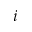Convert formula to latex. <formula><loc_0><loc_0><loc_500><loc_500>i</formula> 